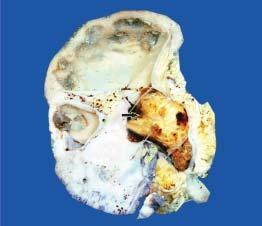what is enlarged and heavy?
Answer the question using a single word or phrase. Kidney 